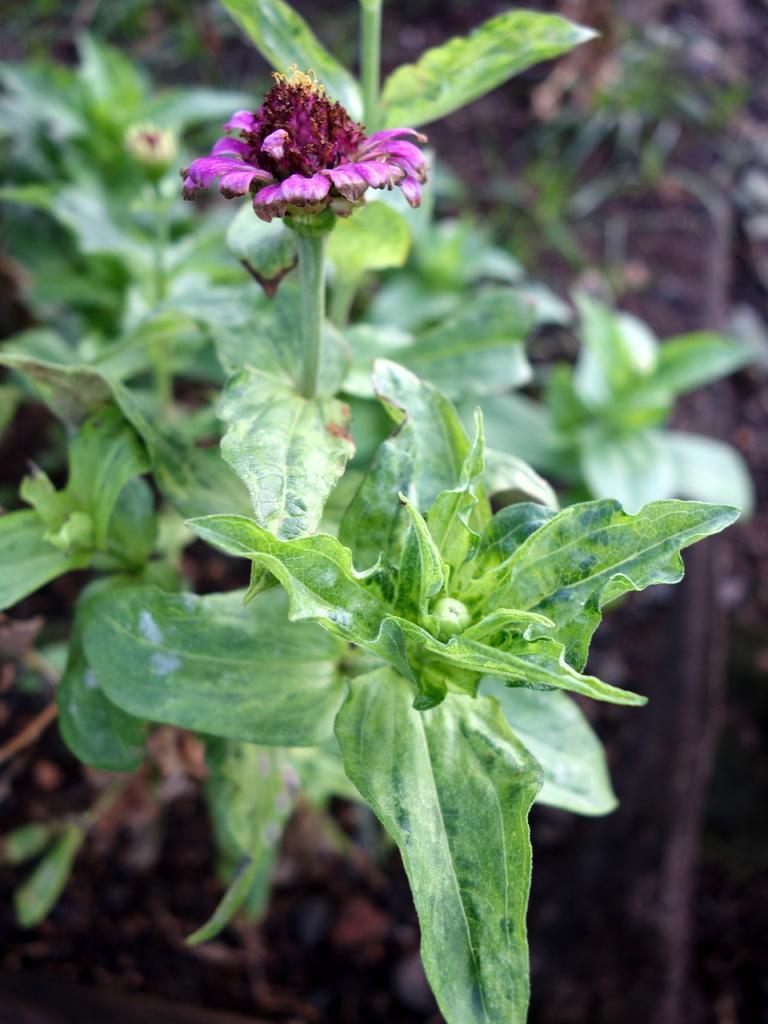Describe this image in one or two sentences. In this picture I can see a plant with a flower, and there is blur background. 